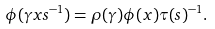<formula> <loc_0><loc_0><loc_500><loc_500>\phi ( \gamma x s ^ { - 1 } ) = \rho ( \gamma ) \phi ( x ) \tau ( s ) ^ { - 1 } .</formula> 